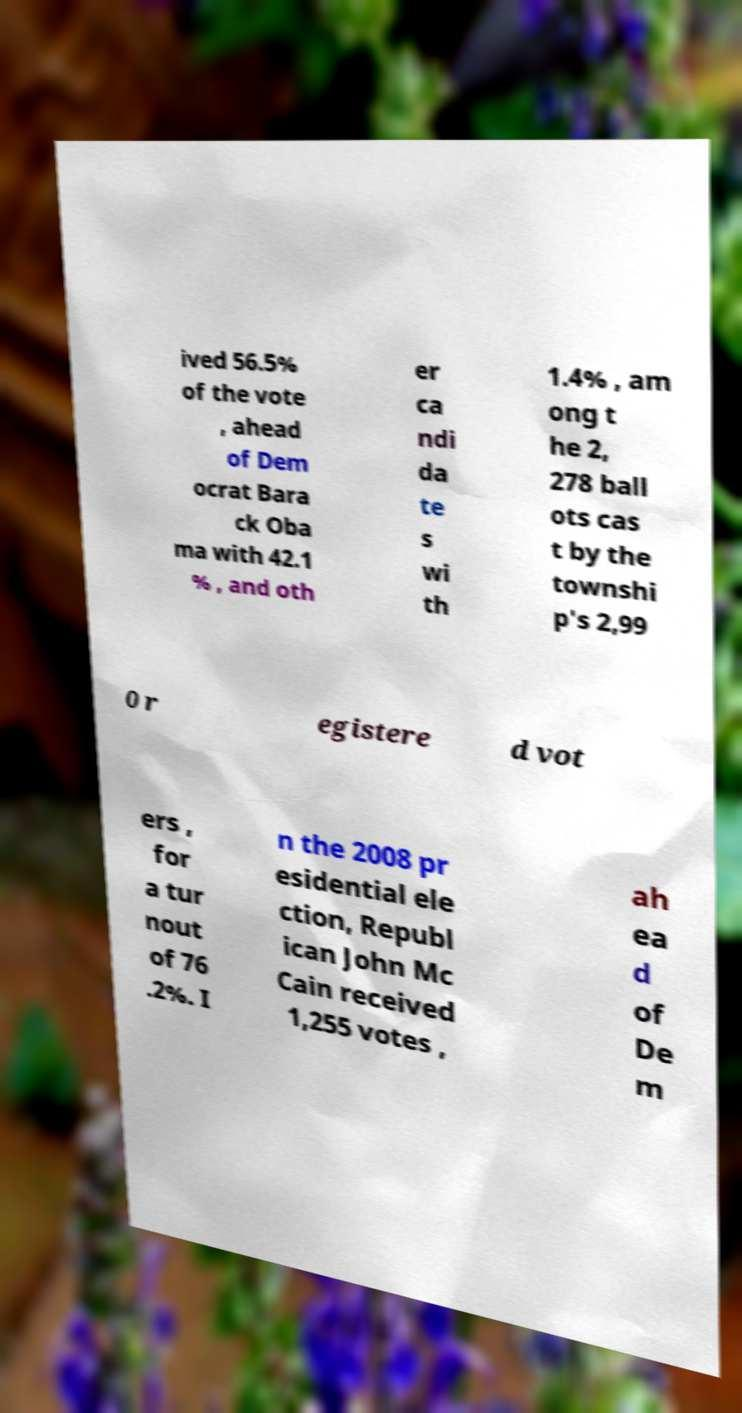Could you assist in decoding the text presented in this image and type it out clearly? ived 56.5% of the vote , ahead of Dem ocrat Bara ck Oba ma with 42.1 % , and oth er ca ndi da te s wi th 1.4% , am ong t he 2, 278 ball ots cas t by the townshi p's 2,99 0 r egistere d vot ers , for a tur nout of 76 .2%. I n the 2008 pr esidential ele ction, Republ ican John Mc Cain received 1,255 votes , ah ea d of De m 